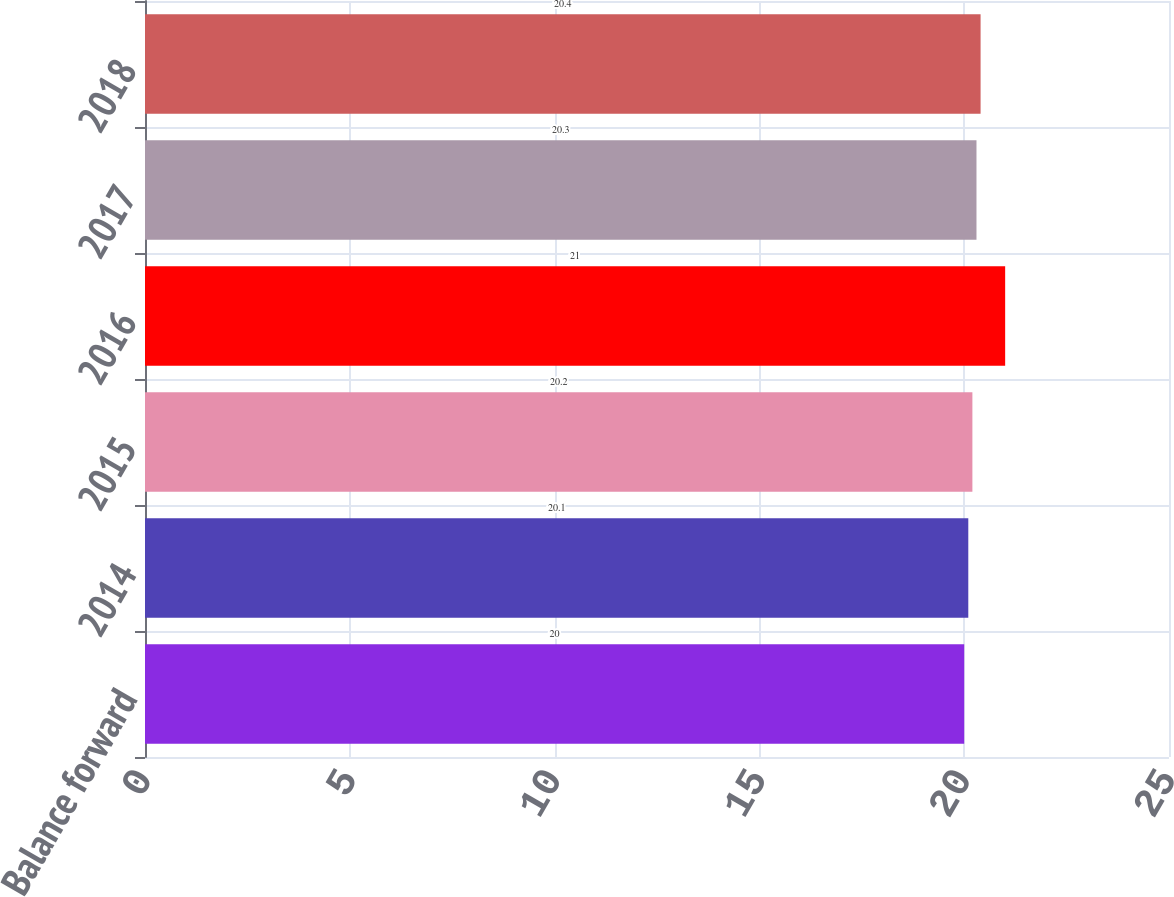<chart> <loc_0><loc_0><loc_500><loc_500><bar_chart><fcel>Balance forward<fcel>2014<fcel>2015<fcel>2016<fcel>2017<fcel>2018<nl><fcel>20<fcel>20.1<fcel>20.2<fcel>21<fcel>20.3<fcel>20.4<nl></chart> 